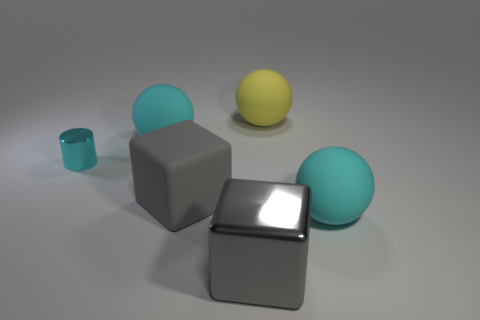What shape is the rubber object that is the same color as the large shiny cube?
Make the answer very short. Cube. How many metallic objects are either red cylinders or cyan cylinders?
Make the answer very short. 1. How many matte objects are both behind the cyan metallic thing and to the right of the big yellow rubber thing?
Ensure brevity in your answer.  0. Are there any other things that have the same shape as the yellow rubber object?
Provide a succinct answer. Yes. What number of other things are the same size as the cyan cylinder?
Make the answer very short. 0. There is a yellow ball that is on the right side of the cyan metal object; is its size the same as the cyan rubber ball in front of the tiny thing?
Provide a succinct answer. Yes. How many things are large gray metallic cylinders or large objects in front of the yellow rubber ball?
Offer a terse response. 4. There is a cyan ball that is in front of the tiny cyan shiny thing; what is its size?
Offer a very short reply. Large. Is the number of gray rubber cubes on the left side of the small cyan cylinder less than the number of gray metal objects to the left of the gray metal block?
Give a very brief answer. No. There is a cyan thing that is both on the left side of the gray matte cube and right of the small cyan cylinder; what material is it?
Keep it short and to the point. Rubber. 